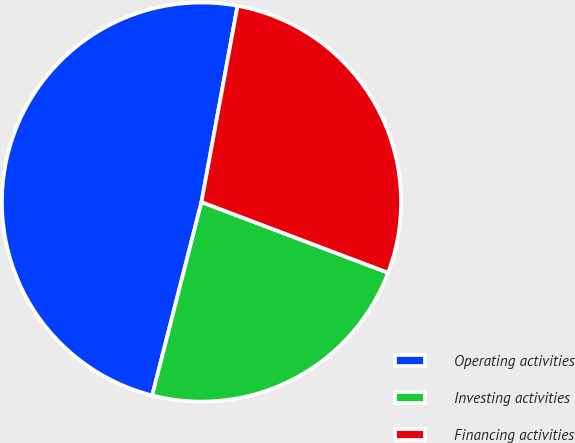Convert chart to OTSL. <chart><loc_0><loc_0><loc_500><loc_500><pie_chart><fcel>Operating activities<fcel>Investing activities<fcel>Financing activities<nl><fcel>48.92%<fcel>23.21%<fcel>27.87%<nl></chart> 